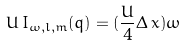<formula> <loc_0><loc_0><loc_500><loc_500>U \, I _ { \omega , l , m } ( q ) = ( \frac { U } { 4 } \Delta \, x ) \omega</formula> 